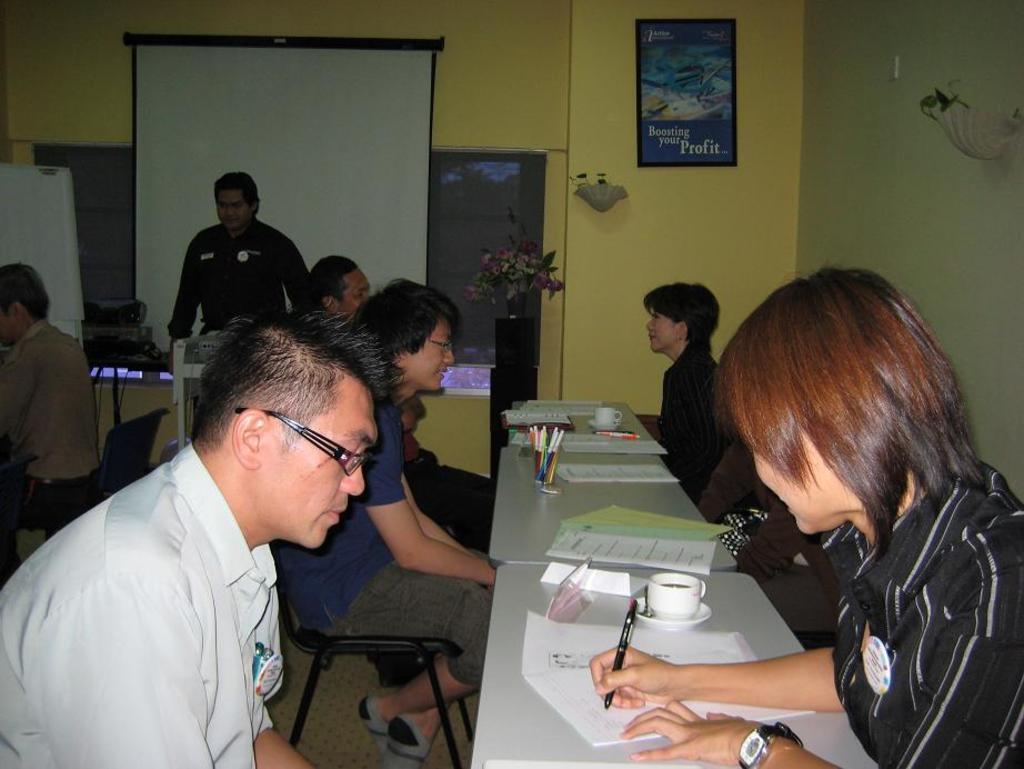How would you summarize this image in a sentence or two? In the foreground of this image, there are papers, cups, pen holders and pens on the tables. On either side to the tables, there are people sitting on the chairs. In the background, there is a flower vase, a projector screen, few electronic devices, a man standing and a man sitting on the chair, window blind, lamps and a frame on the wall. 